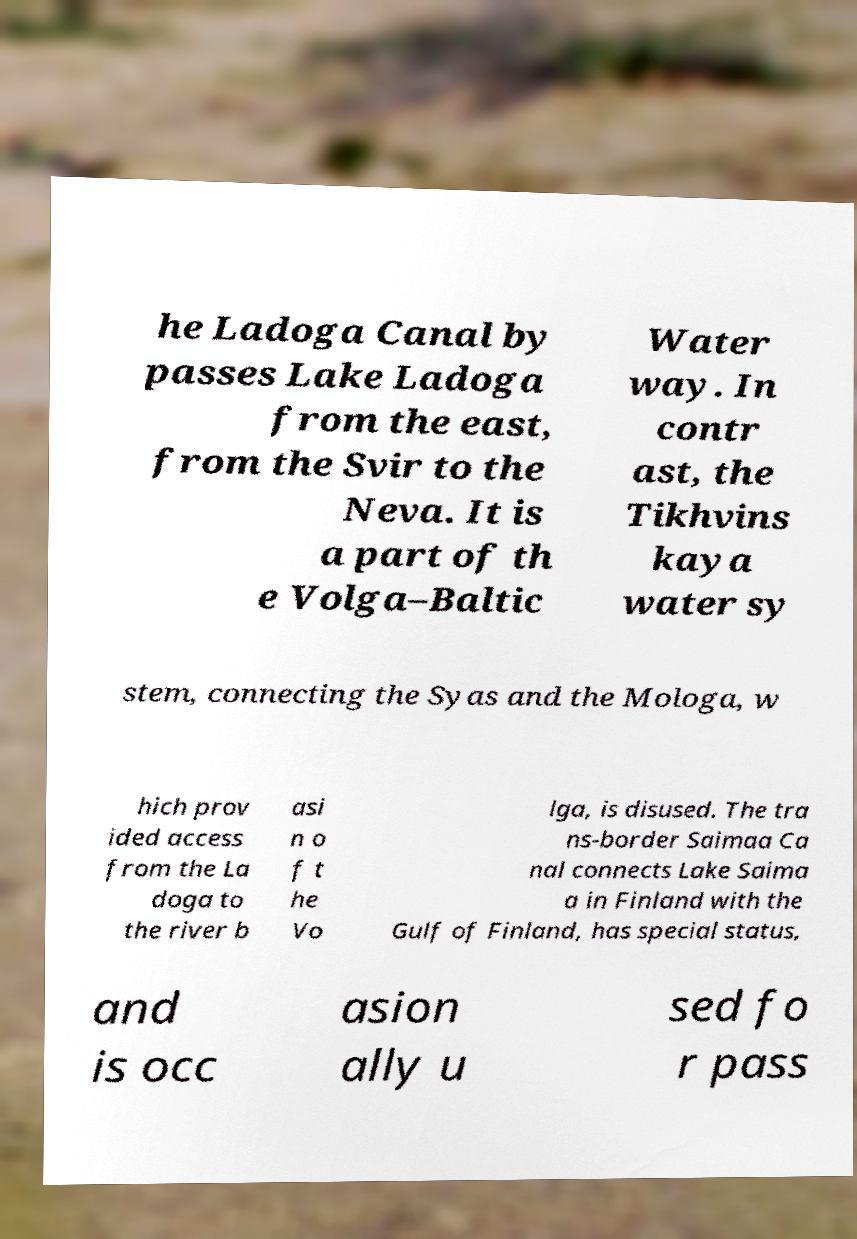Please read and relay the text visible in this image. What does it say? he Ladoga Canal by passes Lake Ladoga from the east, from the Svir to the Neva. It is a part of th e Volga–Baltic Water way. In contr ast, the Tikhvins kaya water sy stem, connecting the Syas and the Mologa, w hich prov ided access from the La doga to the river b asi n o f t he Vo lga, is disused. The tra ns-border Saimaa Ca nal connects Lake Saima a in Finland with the Gulf of Finland, has special status, and is occ asion ally u sed fo r pass 